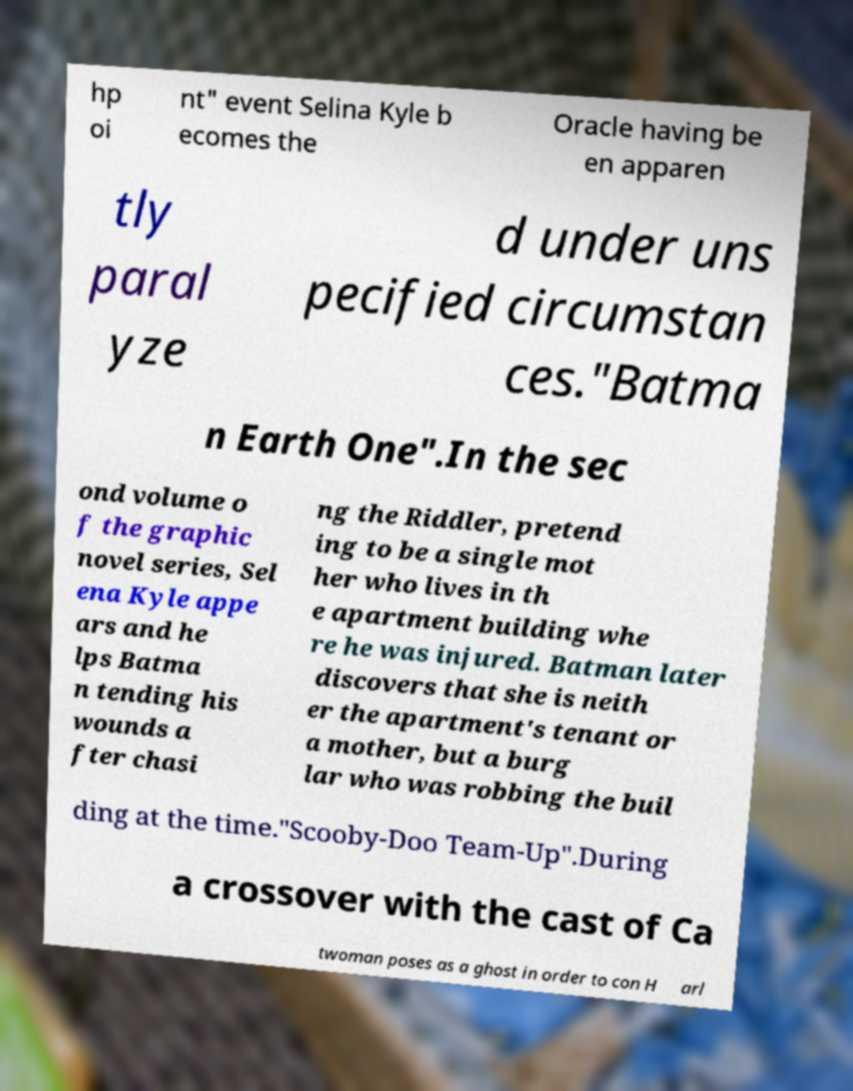There's text embedded in this image that I need extracted. Can you transcribe it verbatim? hp oi nt" event Selina Kyle b ecomes the Oracle having be en apparen tly paral yze d under uns pecified circumstan ces."Batma n Earth One".In the sec ond volume o f the graphic novel series, Sel ena Kyle appe ars and he lps Batma n tending his wounds a fter chasi ng the Riddler, pretend ing to be a single mot her who lives in th e apartment building whe re he was injured. Batman later discovers that she is neith er the apartment's tenant or a mother, but a burg lar who was robbing the buil ding at the time."Scooby-Doo Team-Up".During a crossover with the cast of Ca twoman poses as a ghost in order to con H arl 